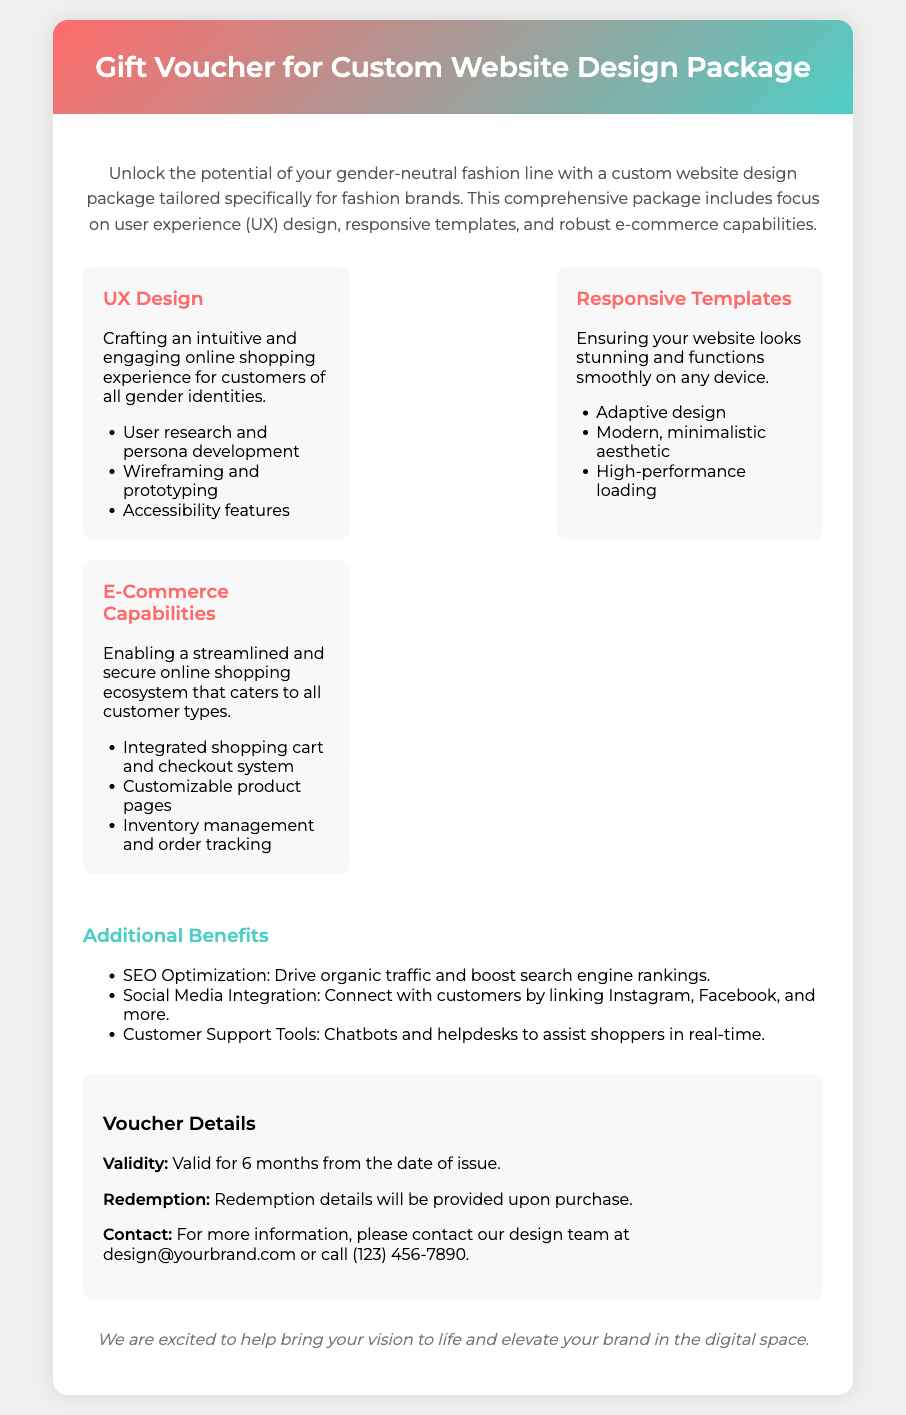What is the title of the document? The title is stated in the header section of the document as "Gift Voucher for Custom Website Design Package."
Answer: Gift Voucher for Custom Website Design Package What are the three main features included in the package? The document lists three features: UX Design, Responsive Templates, and E-Commerce Capabilities.
Answer: UX Design, Responsive Templates, E-Commerce Capabilities How long is the voucher valid for? The voucher details section states that the voucher is valid for a specific duration.
Answer: 6 months What is the email contact for more information? The contact information section provides an email address for inquiries; it's part of the details regarding voucher redemption.
Answer: design@yourbrand.com What benefit is associated with SEO Optimization? The document explains that SEO Optimization is aimed at enhancing a specific metric for the website.
Answer: Drive organic traffic What does the UX Design focus on? The document gives a brief description of what the UX Design entails, outlining its primary objective.
Answer: Engaging online shopping experience Which two social media platforms are mentioned for integration? The document refers to connecting with customers through specific social media platforms.
Answer: Instagram, Facebook What type of aesthetic do the responsive templates emphasize? The description of responsive templates includes a particular style focus regarding the website's appearance.
Answer: Modern, minimalistic aesthetic 